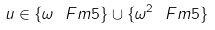<formula> <loc_0><loc_0><loc_500><loc_500>u \in \{ \omega \ F m { 5 } \} \cup \{ \omega ^ { 2 } \ F m { 5 } \}</formula> 